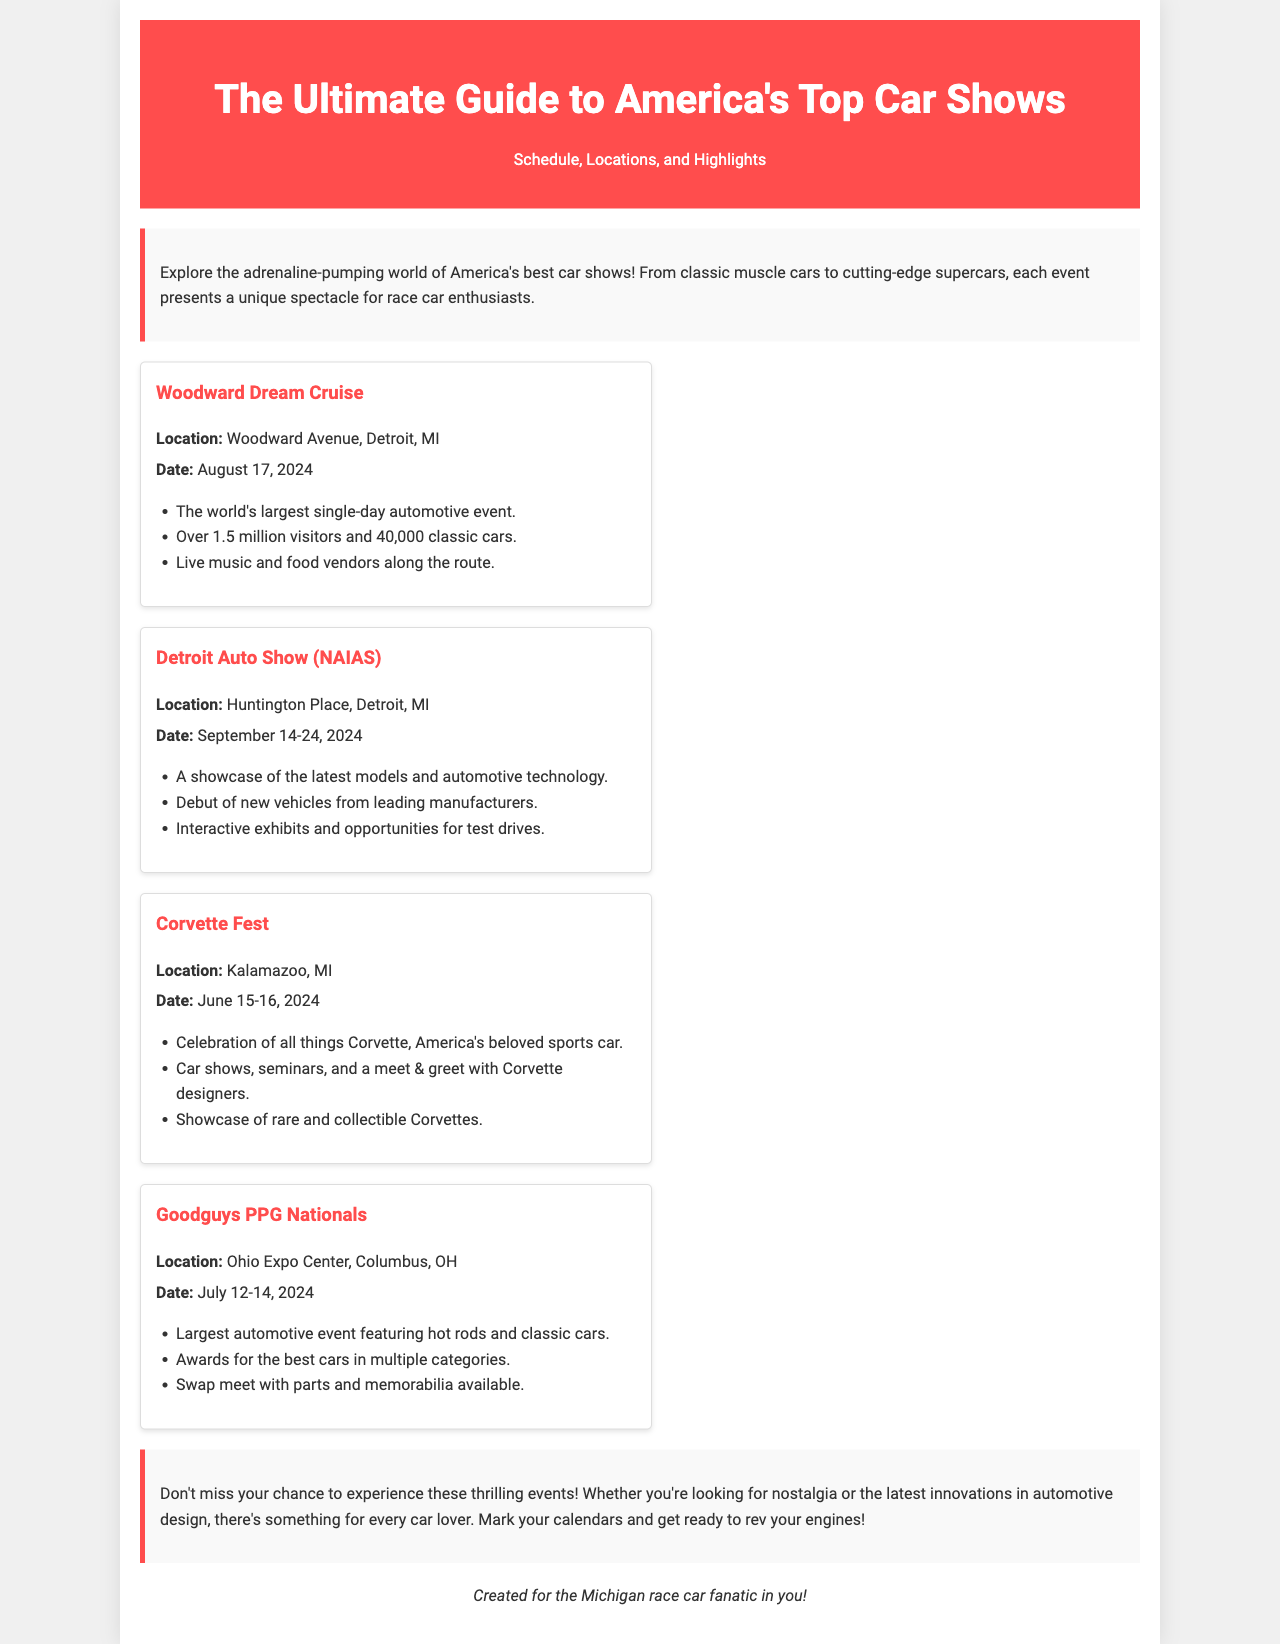What is the location of the Woodward Dream Cruise? The location is specified in the document as Woodward Avenue, Detroit, MI.
Answer: Woodward Avenue, Detroit, MI When is the Detroit Auto Show taking place? The document provides the date for the Detroit Auto Show as September 14-24, 2024.
Answer: September 14-24, 2024 What type of event is Corvette Fest? The document describes Corvette Fest as a celebration of all things Corvette.
Answer: Celebration of all things Corvette How many classic cars are expected at the Woodward Dream Cruise? The document states that there will be over 40,000 classic cars at the event.
Answer: 40,000 classic cars What is the largest automotive event according to the document? The title of the Woodward Dream Cruise highlights it as the world's largest single-day automotive event, which allows for the identification of the largest event.
Answer: Woodward Dream Cruise What is the main focus of the Goodguys PPG Nationals? The document indicates that the event features hot rods and classic cars as its main focus.
Answer: Hot rods and classic cars Name one activity available at the Detroit Auto Show. The document mentions interactive exhibits as one of the activities available at the Detroit Auto Show.
Answer: Interactive exhibits When is Corvette Fest scheduled? According to the document, Corvette Fest is scheduled for June 15-16, 2024.
Answer: June 15-16, 2024 Who is the brochure created for? The document specifies that it is created for the Michigan race car fanatic.
Answer: Michigan race car fanatic 